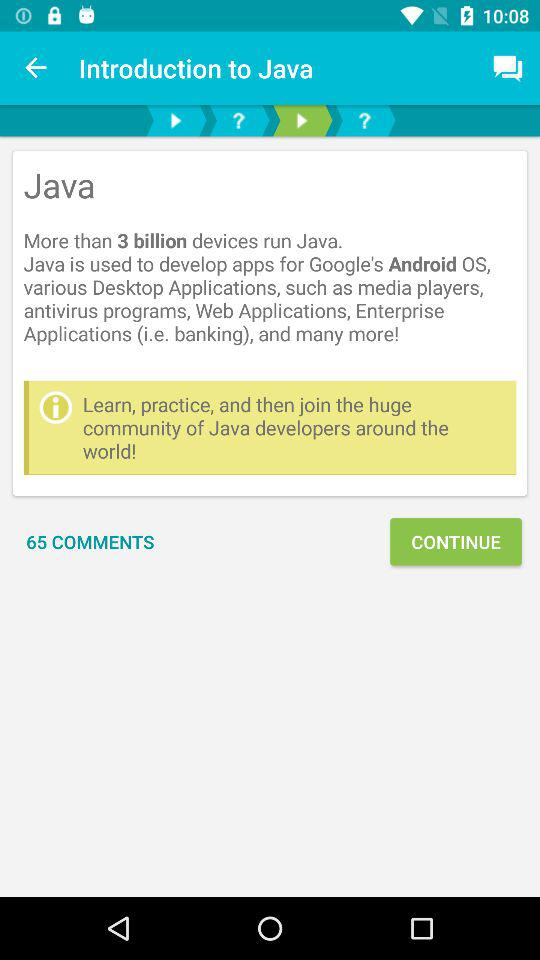How can we access the device location?
When the provided information is insufficient, respond with <no answer>. <no answer> 